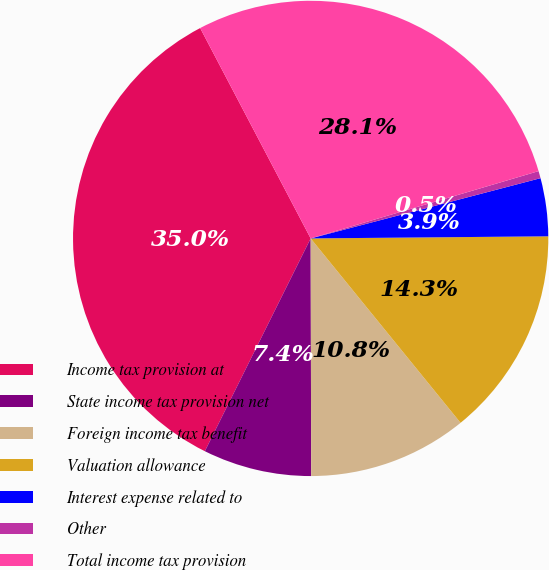Convert chart. <chart><loc_0><loc_0><loc_500><loc_500><pie_chart><fcel>Income tax provision at<fcel>State income tax provision net<fcel>Foreign income tax benefit<fcel>Valuation allowance<fcel>Interest expense related to<fcel>Other<fcel>Total income tax provision<nl><fcel>34.96%<fcel>7.38%<fcel>10.83%<fcel>14.28%<fcel>3.94%<fcel>0.49%<fcel>28.13%<nl></chart> 